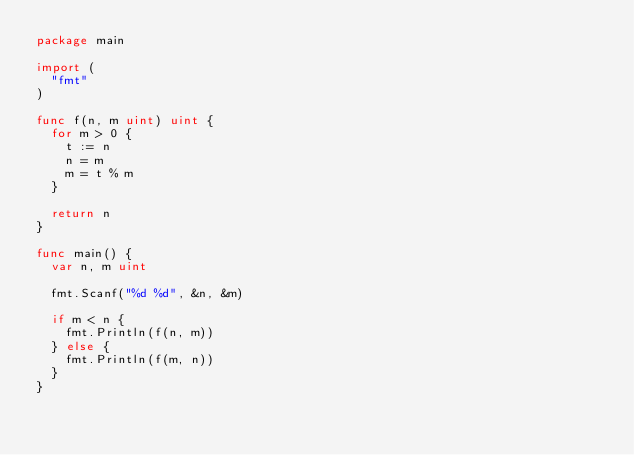<code> <loc_0><loc_0><loc_500><loc_500><_Go_>package main

import (
	"fmt"
)

func f(n, m uint) uint {
	for m > 0 {
		t := n
		n = m
		m = t % m
	}

	return n
}

func main() {
	var n, m uint

	fmt.Scanf("%d %d", &n, &m)

	if m < n {
		fmt.Println(f(n, m))
	} else {
		fmt.Println(f(m, n))
	}
}

</code> 